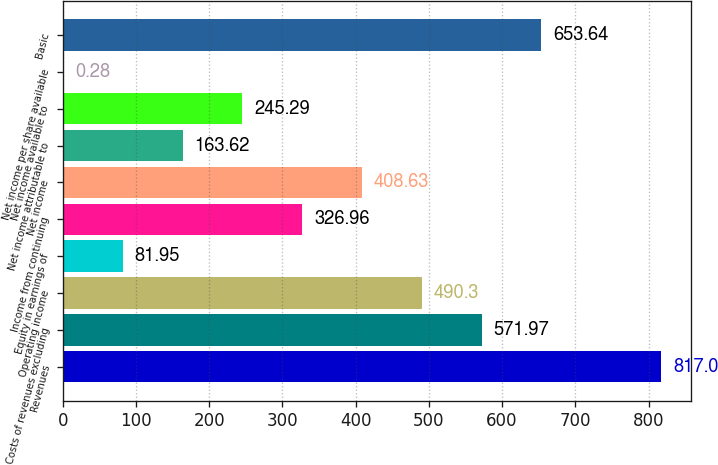<chart> <loc_0><loc_0><loc_500><loc_500><bar_chart><fcel>Revenues<fcel>Costs of revenues excluding<fcel>Operating income<fcel>Equity in earnings of<fcel>Income from continuing<fcel>Net income<fcel>Net income attributable to<fcel>Net income available to<fcel>Net income per share available<fcel>Basic<nl><fcel>817<fcel>571.97<fcel>490.3<fcel>81.95<fcel>326.96<fcel>408.63<fcel>163.62<fcel>245.29<fcel>0.28<fcel>653.64<nl></chart> 